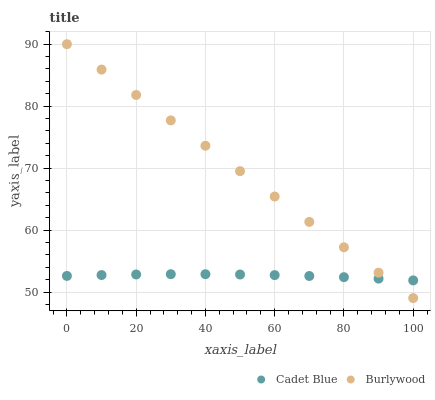Does Cadet Blue have the minimum area under the curve?
Answer yes or no. Yes. Does Burlywood have the maximum area under the curve?
Answer yes or no. Yes. Does Cadet Blue have the maximum area under the curve?
Answer yes or no. No. Is Burlywood the smoothest?
Answer yes or no. Yes. Is Cadet Blue the roughest?
Answer yes or no. Yes. Is Cadet Blue the smoothest?
Answer yes or no. No. Does Burlywood have the lowest value?
Answer yes or no. Yes. Does Cadet Blue have the lowest value?
Answer yes or no. No. Does Burlywood have the highest value?
Answer yes or no. Yes. Does Cadet Blue have the highest value?
Answer yes or no. No. Does Burlywood intersect Cadet Blue?
Answer yes or no. Yes. Is Burlywood less than Cadet Blue?
Answer yes or no. No. Is Burlywood greater than Cadet Blue?
Answer yes or no. No. 